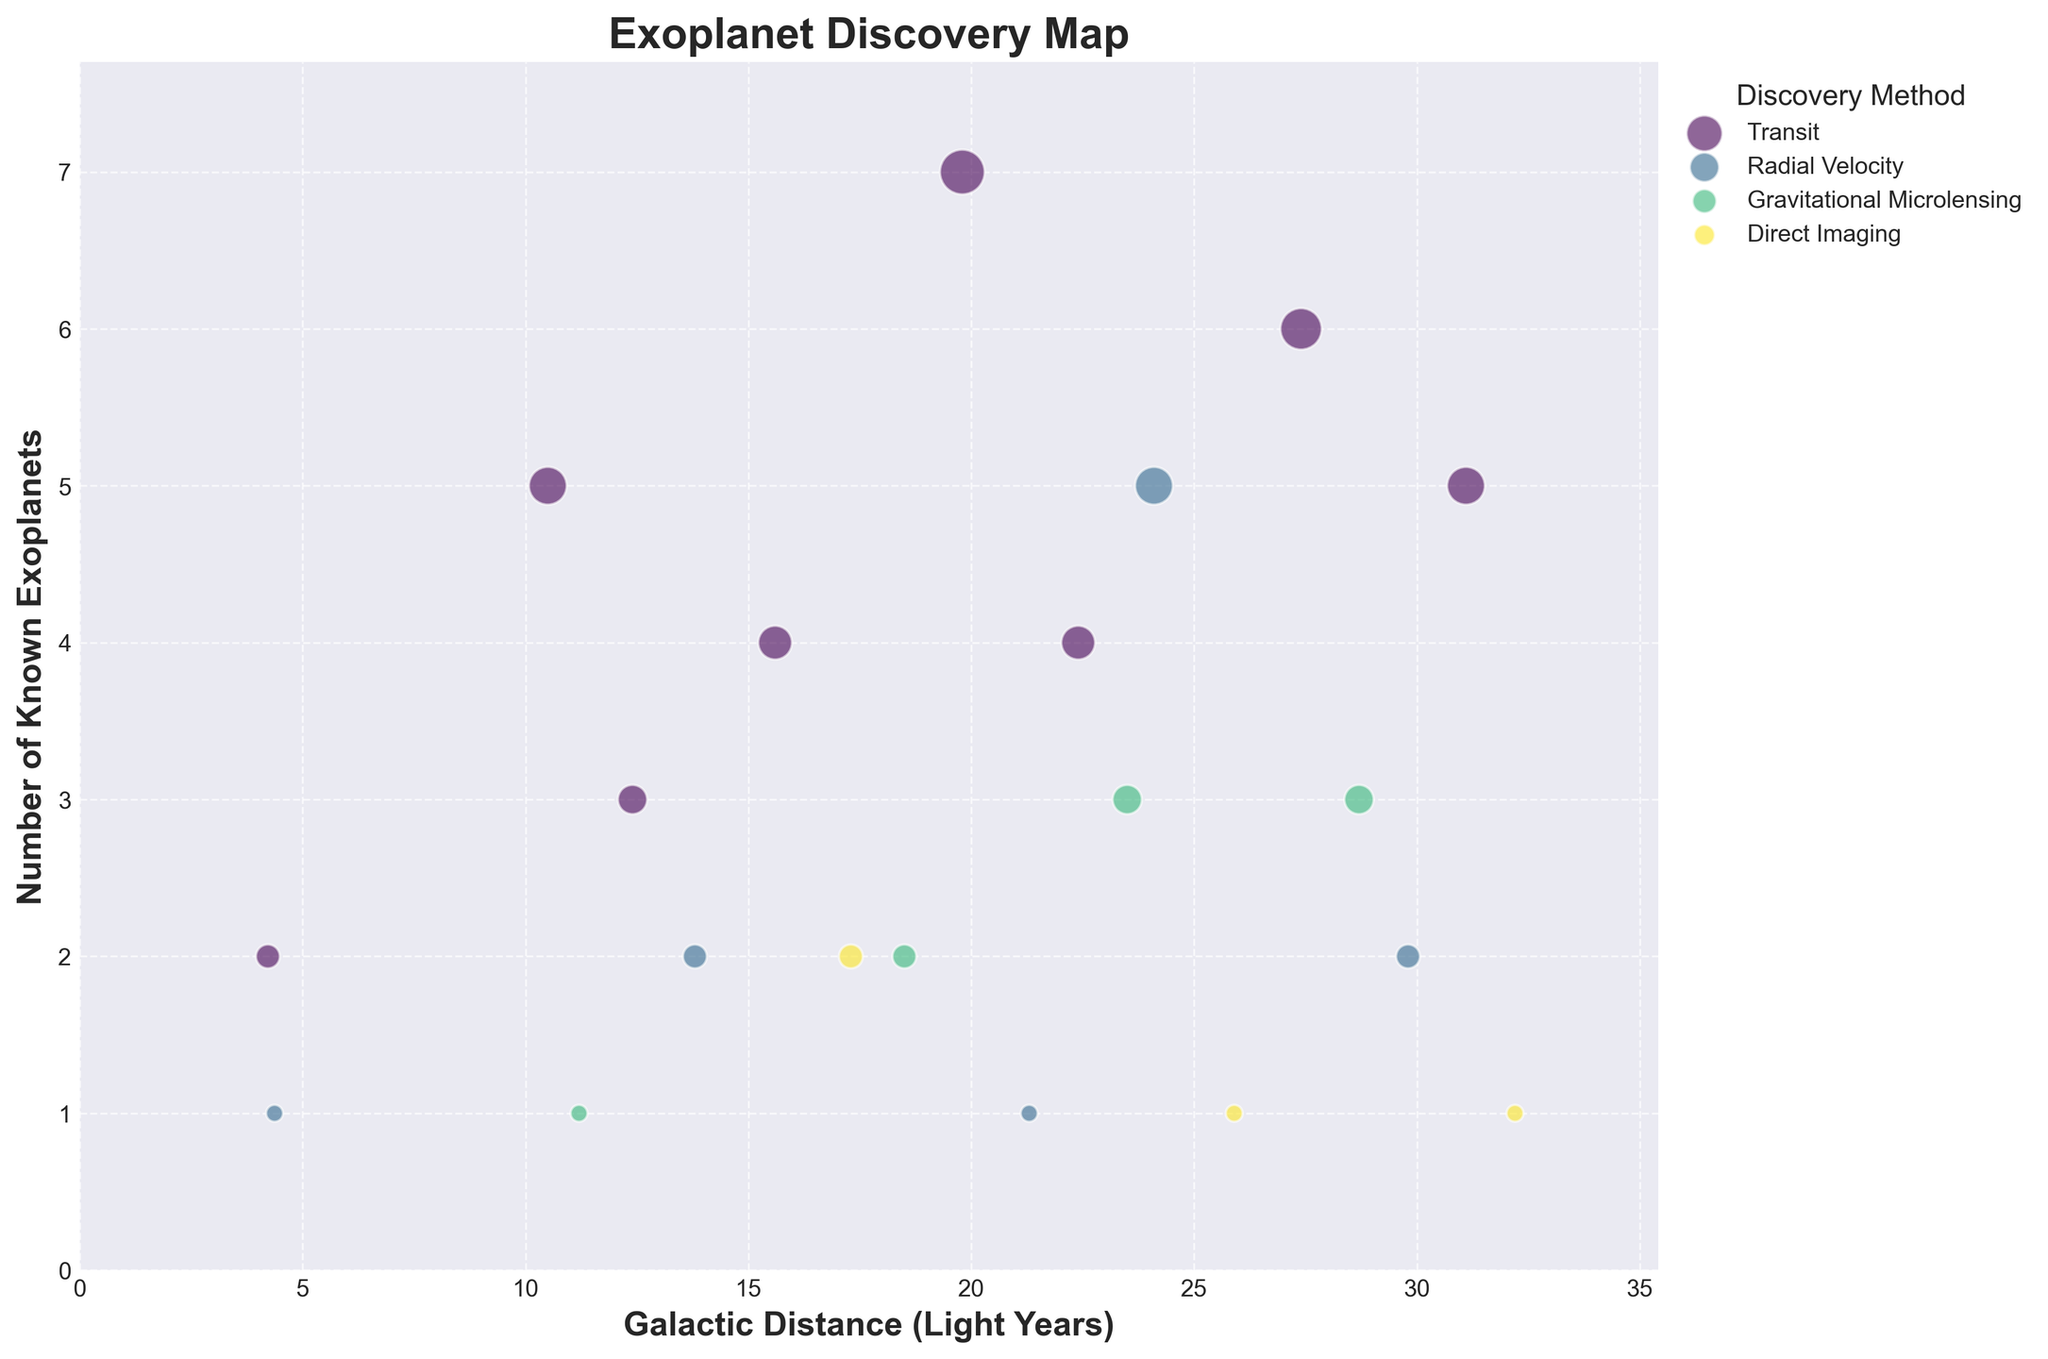What is the title of the figure? The title is usually located at the top of the chart. It succinctly describes the overall theme or purpose of the chart. Here, the title of the figure is written in bold letters at the top.
Answer: Exoplanet Discovery Map How many exoplanets were discovered using the Direct Imaging method? Find the bubbles representing the Direct Imaging method, identify their sizes, and sum the corresponding numbers of known exoplanets. There are three bubbles for Direct Imaging with sizes representing 2, 1, and 1 exoplanets respectively. Sum them up: 2 + 1 + 1 = 4
Answer: 4 Which discovery method has the highest number of exoplanets within 25 light years? Observe the bubbles within the 25 light years range and check the legend for the color representing each discovery method. Identify the bubbles and their corresponding discovery methods, then sum the number of exoplanets for each method. The Transit method has 2 + 5 + 3 + 4 = 14 exoplanets.
Answer: Transit What is the method with the highest single-bubble number of exoplanets and how many exoplanets does that bubble represent? Identify the largest bubbles on the chart and check the corresponding discovery method and the number of exoplanets they represent based on the legend. The largest single bubble represents 7 exoplanets discovered by the Transit method.
Answer: Transit, 7 exoplanets What is the average number of exoplanets found using the Gravitational Microlensing method? List the bubbles for Gravitational Microlensing and note their sizes, then calculate the average. The sizes are 1, 2, 3, and 3 exoplanets. The total is 1 + 2 + 3 + 3 = 9, and there are 4 bubbles, so the average is 9/4 = 2.25
Answer: 2.25 Compared to the Radial Velocity method, are there more or fewer exoplanets discovered using the Transit method? By how many? Sum the sizes of bubbles for Radial Velocity and Transit methods and compare. Radial Velocity has 1 + 2 + 1 + 5 = 9 exoplanets. Transit has 2 + 5 + 3 + 4 + 7 + 4 + 6 + 5 = 36 exoplanets. The difference is 36 - 9 = 27.
Answer: More, 27 Which discovery method has the most even distribution of exoplanet numbers across different galactic distances? Observe the spread of bubbles along the galactic distance axis for each method. The Transit method appears to have bubbles spaced out evenly along the axis, indicating a consistent discovery rate across distances.
Answer: Transit What is the total number of known exoplanets displayed in the chart? Sum the number of exoplanets across all bubbles, from each discovery method. Total is 2 + 1 + 5 + 1 + 3 + 2 + 4 + 2 + 2 + 7 + 1 + 4 + 3 + 5 + 1 + 6 + 3 + 2 + 5 + 1 = 60
Answer: 60 What is the galactic distance range where exoplanets discovered by Gravitational Microlensing are found? Look at the bubbles color-coded for Gravitational Microlensing and note the minimum and maximum galactic distances. They range from approximately 11.2 to 28.7 light years.
Answer: 11.2 to 28.7 light years 